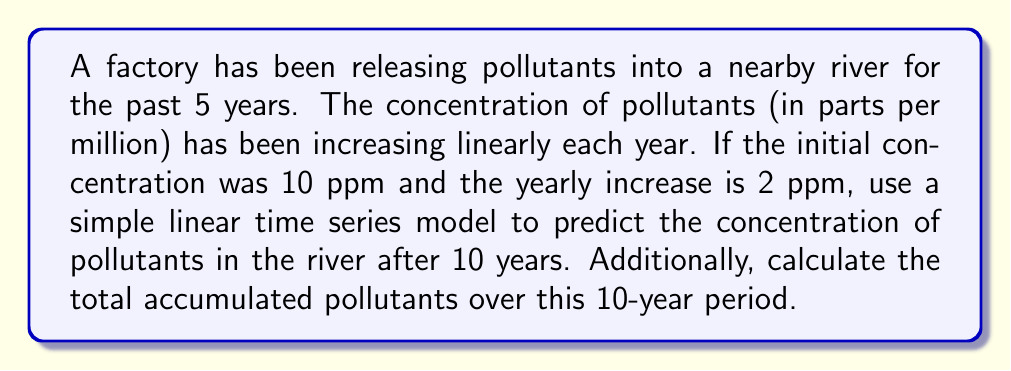Teach me how to tackle this problem. To solve this problem, we'll use a simple linear time series model:

1. Let $y_t$ be the concentration of pollutants at time $t$ (in years).
2. The model can be expressed as: $y_t = a + bt$, where $a$ is the initial concentration and $b$ is the yearly increase.

Given:
- Initial concentration $(a) = 10$ ppm
- Yearly increase $(b) = 2$ ppm/year
- Time period $(t) = 10$ years

Step 1: Predict the concentration after 10 years
$$y_{10} = a + bt = 10 + 2(10) = 10 + 20 = 30 \text{ ppm}$$

Step 2: Calculate the total accumulated pollutants
To find the total accumulation, we need to sum the concentrations for each year from 0 to 10.
This forms an arithmetic sequence with 11 terms (years 0 to 10, inclusive).

First term $(a_1) = 10$ ppm
Last term $(a_{11}) = 30$ ppm
Number of terms $(n) = 11$

Using the formula for the sum of an arithmetic sequence:
$$S_n = \frac{n}{2}(a_1 + a_n)$$

$$S_{11} = \frac{11}{2}(10 + 30) = \frac{11}{2}(40) = 220 \text{ ppm-years}$$

This represents the total accumulated pollutants over the 10-year period.
Answer: 30 ppm; 220 ppm-years 